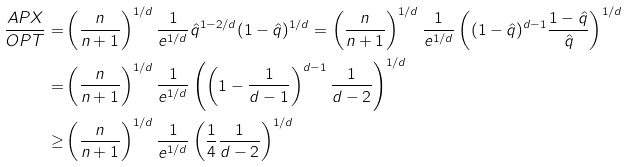Convert formula to latex. <formula><loc_0><loc_0><loc_500><loc_500>\frac { A P X } { O P T } = & \left ( \frac { n } { n + 1 } \right ) ^ { 1 / d } \frac { 1 } { e ^ { 1 / d } } \hat { q } ^ { 1 - 2 / d } ( 1 - \hat { q } ) ^ { 1 / d } = \left ( \frac { n } { n + 1 } \right ) ^ { 1 / d } \frac { 1 } { e ^ { 1 / d } } \left ( ( 1 - \hat { q } ) ^ { d - 1 } \frac { 1 - \hat { q } } { \hat { q } } \right ) ^ { 1 / d } \\ = & \left ( \frac { n } { n + 1 } \right ) ^ { 1 / d } \frac { 1 } { e ^ { 1 / d } } \left ( \left ( 1 - \frac { 1 } { d - 1 } \right ) ^ { d - 1 } \frac { 1 } { d - 2 } \right ) ^ { 1 / d } \\ \geq & \left ( \frac { n } { n + 1 } \right ) ^ { 1 / d } \frac { 1 } { e ^ { 1 / d } } \left ( \frac { 1 } { 4 } \frac { 1 } { d - 2 } \right ) ^ { 1 / d }</formula> 